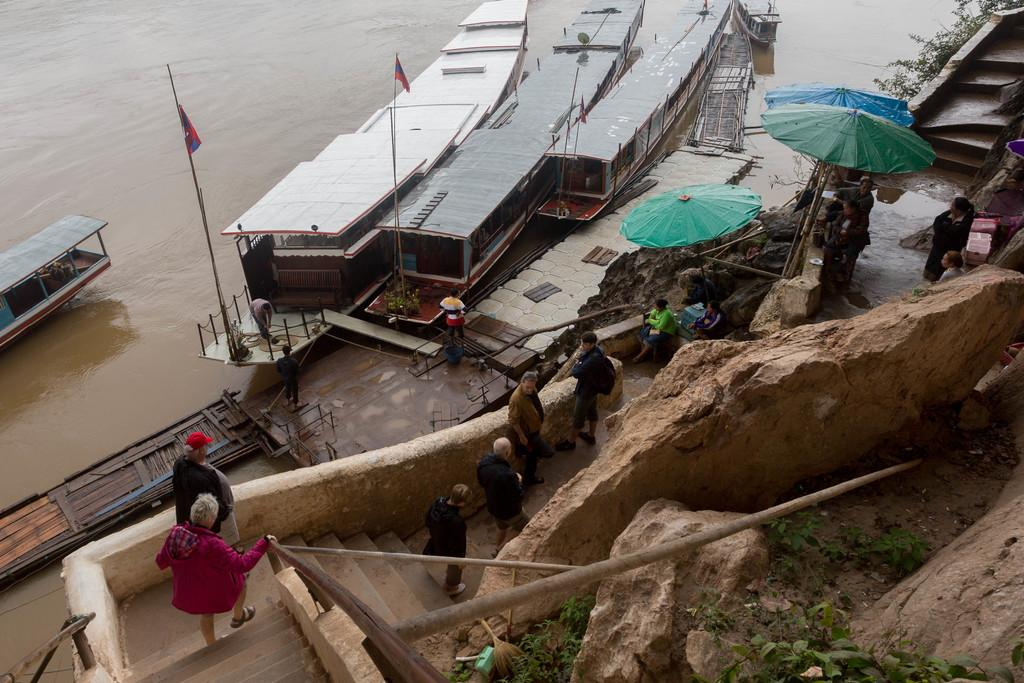What type of vehicles can be seen in the image? There are boats in the image. What decorative or symbolic items are present in the image? There are flags in the image. Who or what is present in the image? There are people in the image. What architectural feature can be seen in the image? There are steps in the image. What type of protection from the elements is visible in the image? There are umbrellas in the image. What natural elements can be seen in the image? There are rocks and leaves in the image. What unspecified objects are present in the image? There are unspecified objects in the image. What type of plantation is visible in the image? There is no plantation present in the image. What letters can be seen on the boats in the image? There is no mention of letters on the boats in the image. What type of weather condition can be seen in the image? The provided facts do not mention any weather conditions, such as thunder, in the image. 